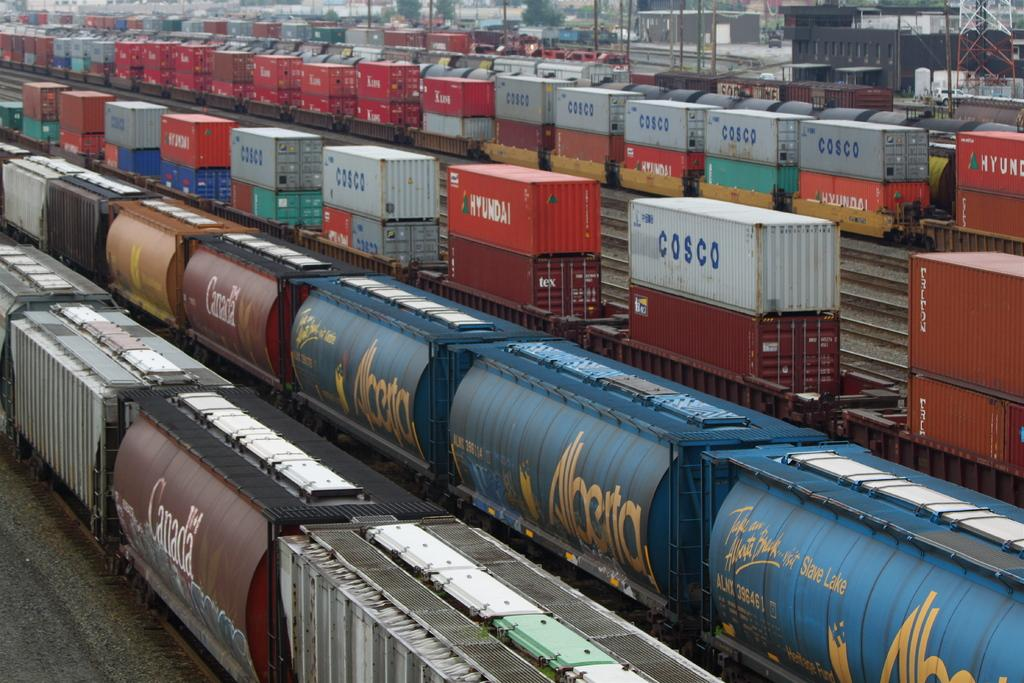Provide a one-sentence caption for the provided image. An industrial area with many Cosco shipping containers stacked up in rows. 